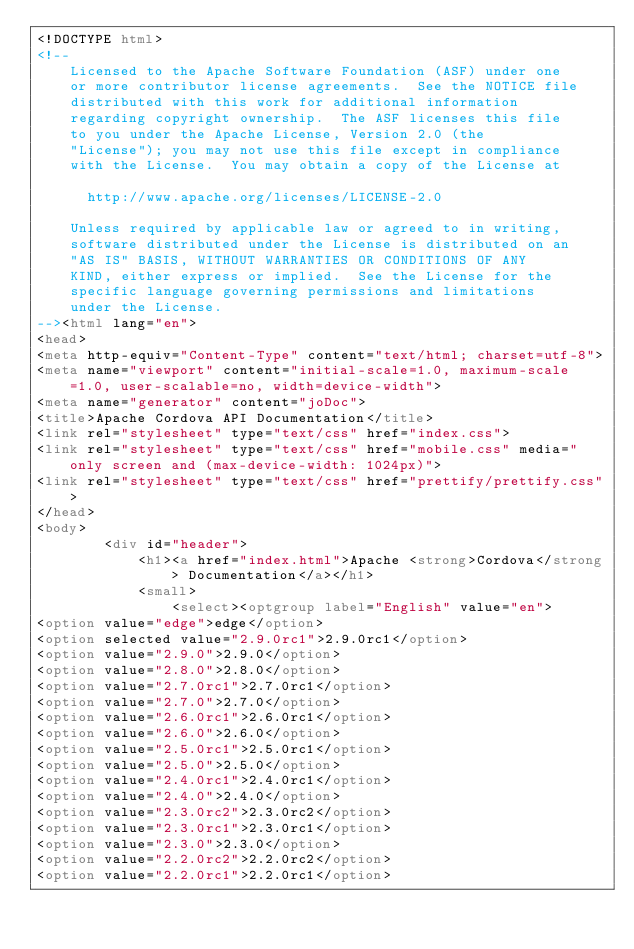<code> <loc_0><loc_0><loc_500><loc_500><_HTML_><!DOCTYPE html>
<!--
    Licensed to the Apache Software Foundation (ASF) under one
    or more contributor license agreements.  See the NOTICE file
    distributed with this work for additional information
    regarding copyright ownership.  The ASF licenses this file
    to you under the Apache License, Version 2.0 (the
    "License"); you may not use this file except in compliance
    with the License.  You may obtain a copy of the License at

      http://www.apache.org/licenses/LICENSE-2.0

    Unless required by applicable law or agreed to in writing,
    software distributed under the License is distributed on an
    "AS IS" BASIS, WITHOUT WARRANTIES OR CONDITIONS OF ANY
    KIND, either express or implied.  See the License for the
    specific language governing permissions and limitations
    under the License.
--><html lang="en">
<head>
<meta http-equiv="Content-Type" content="text/html; charset=utf-8">
<meta name="viewport" content="initial-scale=1.0, maximum-scale=1.0, user-scalable=no, width=device-width">
<meta name="generator" content="joDoc">
<title>Apache Cordova API Documentation</title>
<link rel="stylesheet" type="text/css" href="index.css">
<link rel="stylesheet" type="text/css" href="mobile.css" media="only screen and (max-device-width: 1024px)">
<link rel="stylesheet" type="text/css" href="prettify/prettify.css">
</head>
<body>
        <div id="header">
            <h1><a href="index.html">Apache <strong>Cordova</strong> Documentation</a></h1>
            <small>
                <select><optgroup label="English" value="en">
<option value="edge">edge</option>
<option selected value="2.9.0rc1">2.9.0rc1</option>
<option value="2.9.0">2.9.0</option>
<option value="2.8.0">2.8.0</option>
<option value="2.7.0rc1">2.7.0rc1</option>
<option value="2.7.0">2.7.0</option>
<option value="2.6.0rc1">2.6.0rc1</option>
<option value="2.6.0">2.6.0</option>
<option value="2.5.0rc1">2.5.0rc1</option>
<option value="2.5.0">2.5.0</option>
<option value="2.4.0rc1">2.4.0rc1</option>
<option value="2.4.0">2.4.0</option>
<option value="2.3.0rc2">2.3.0rc2</option>
<option value="2.3.0rc1">2.3.0rc1</option>
<option value="2.3.0">2.3.0</option>
<option value="2.2.0rc2">2.2.0rc2</option>
<option value="2.2.0rc1">2.2.0rc1</option></code> 